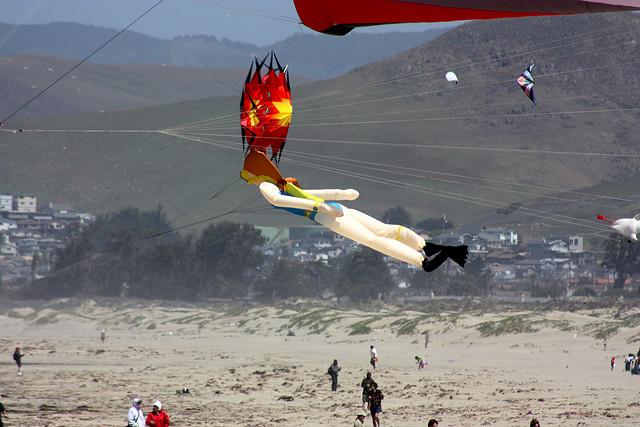Can you describe what could be happening in the scene? It appears to be a vibrant kite-flying event taking place on a beach. The participants are scattered across the sandy area, either engaged in flying their kites or observing the colorful displays in the sky. The kites range from simple geometric shapes to more elaborate designs, such as the prominent humanoid kite, suggesting a festive or competitive gathering. The weather seems cool, as indicated by the jackets worn by the individuals. The backdrop of hills and a coastal town adds to the recreational atmosphere of the beachside event. 